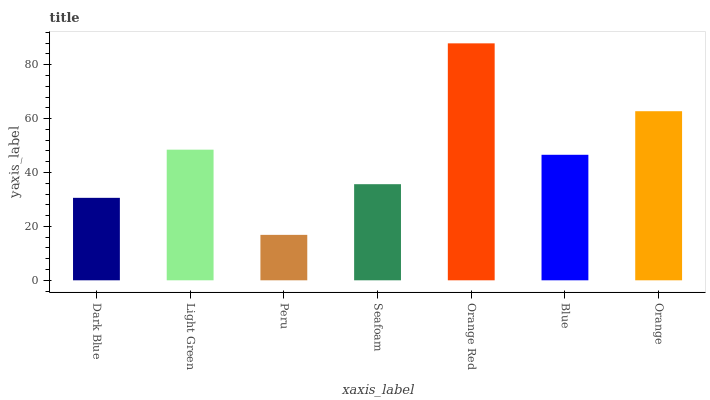Is Peru the minimum?
Answer yes or no. Yes. Is Orange Red the maximum?
Answer yes or no. Yes. Is Light Green the minimum?
Answer yes or no. No. Is Light Green the maximum?
Answer yes or no. No. Is Light Green greater than Dark Blue?
Answer yes or no. Yes. Is Dark Blue less than Light Green?
Answer yes or no. Yes. Is Dark Blue greater than Light Green?
Answer yes or no. No. Is Light Green less than Dark Blue?
Answer yes or no. No. Is Blue the high median?
Answer yes or no. Yes. Is Blue the low median?
Answer yes or no. Yes. Is Peru the high median?
Answer yes or no. No. Is Seafoam the low median?
Answer yes or no. No. 